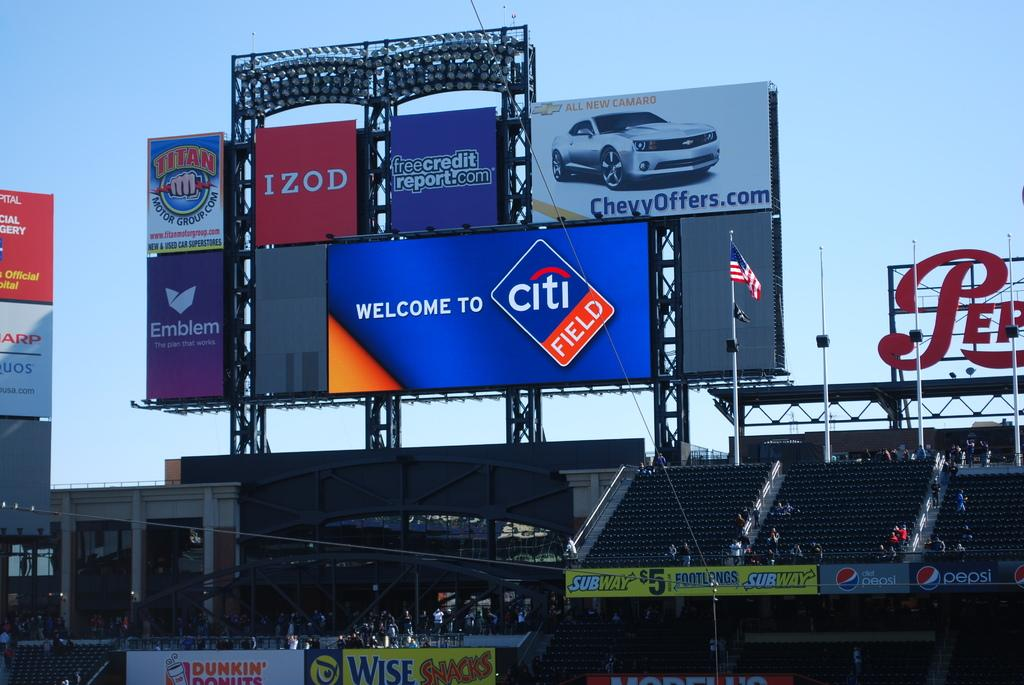<image>
Create a compact narrative representing the image presented. A large electronic board reads welcom to Citi Field. 